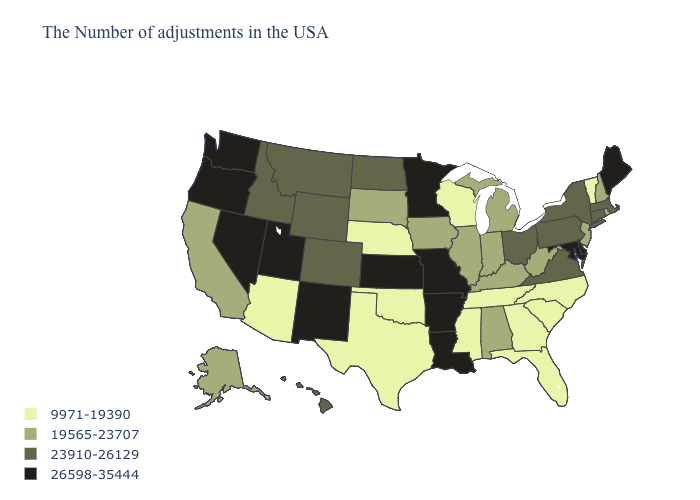What is the lowest value in states that border Utah?
Keep it brief. 9971-19390. Name the states that have a value in the range 19565-23707?
Keep it brief. Rhode Island, New Hampshire, New Jersey, West Virginia, Michigan, Kentucky, Indiana, Alabama, Illinois, Iowa, South Dakota, California, Alaska. Which states have the lowest value in the USA?
Concise answer only. Vermont, North Carolina, South Carolina, Florida, Georgia, Tennessee, Wisconsin, Mississippi, Nebraska, Oklahoma, Texas, Arizona. What is the highest value in the Northeast ?
Write a very short answer. 26598-35444. Is the legend a continuous bar?
Give a very brief answer. No. Does West Virginia have a lower value than Iowa?
Quick response, please. No. What is the value of Hawaii?
Write a very short answer. 23910-26129. Which states have the lowest value in the Northeast?
Quick response, please. Vermont. What is the value of New Hampshire?
Short answer required. 19565-23707. Does Kentucky have the lowest value in the USA?
Be succinct. No. Does Washington have the highest value in the USA?
Write a very short answer. Yes. Does the map have missing data?
Give a very brief answer. No. What is the value of North Carolina?
Quick response, please. 9971-19390. Does Texas have a lower value than Hawaii?
Short answer required. Yes. Name the states that have a value in the range 19565-23707?
Be succinct. Rhode Island, New Hampshire, New Jersey, West Virginia, Michigan, Kentucky, Indiana, Alabama, Illinois, Iowa, South Dakota, California, Alaska. 